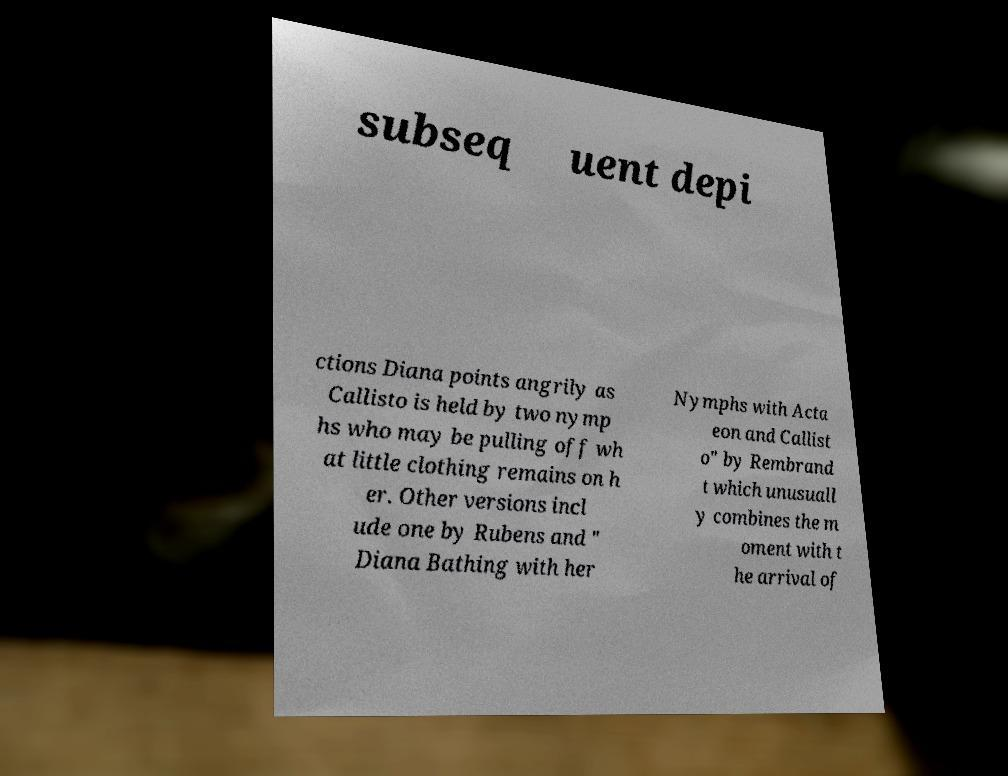What messages or text are displayed in this image? I need them in a readable, typed format. subseq uent depi ctions Diana points angrily as Callisto is held by two nymp hs who may be pulling off wh at little clothing remains on h er. Other versions incl ude one by Rubens and " Diana Bathing with her Nymphs with Acta eon and Callist o" by Rembrand t which unusuall y combines the m oment with t he arrival of 